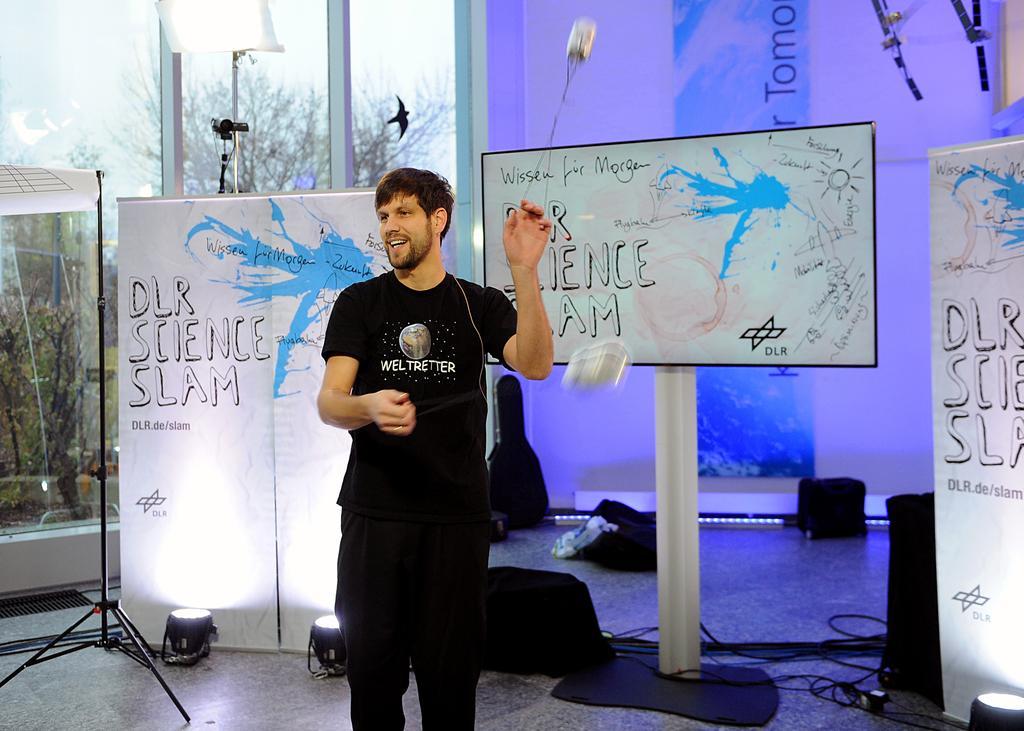Describe this image in one or two sentences. In this picture there is a man who is wearing black dress, beside him we can see boards and focus lights. On the right there is a speaker near to the television screen and banner. On the left we can see the glass door. Through the glass we can see plants, shed, sky and grass. 